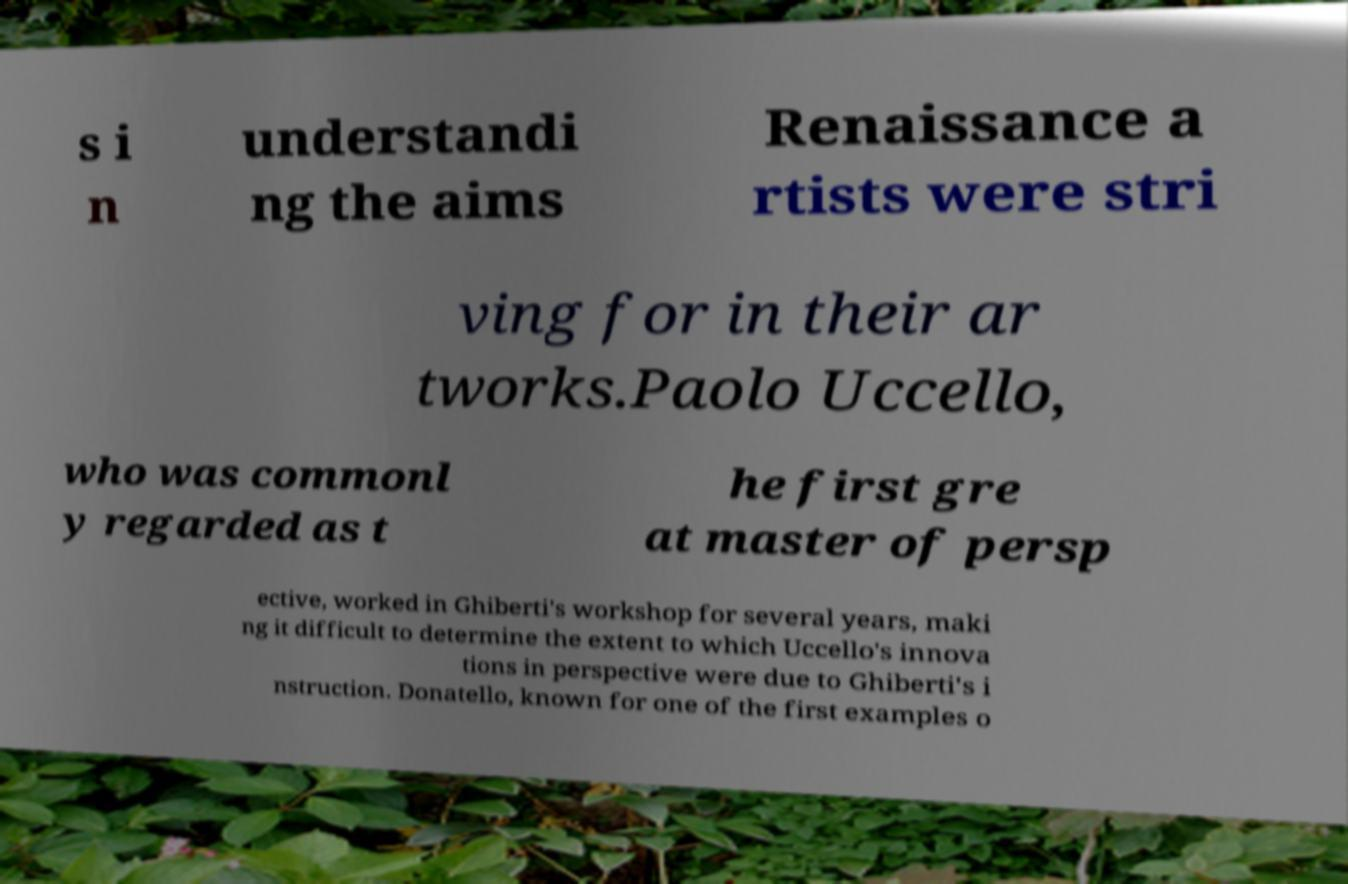What messages or text are displayed in this image? I need them in a readable, typed format. s i n understandi ng the aims Renaissance a rtists were stri ving for in their ar tworks.Paolo Uccello, who was commonl y regarded as t he first gre at master of persp ective, worked in Ghiberti's workshop for several years, maki ng it difficult to determine the extent to which Uccello's innova tions in perspective were due to Ghiberti's i nstruction. Donatello, known for one of the first examples o 